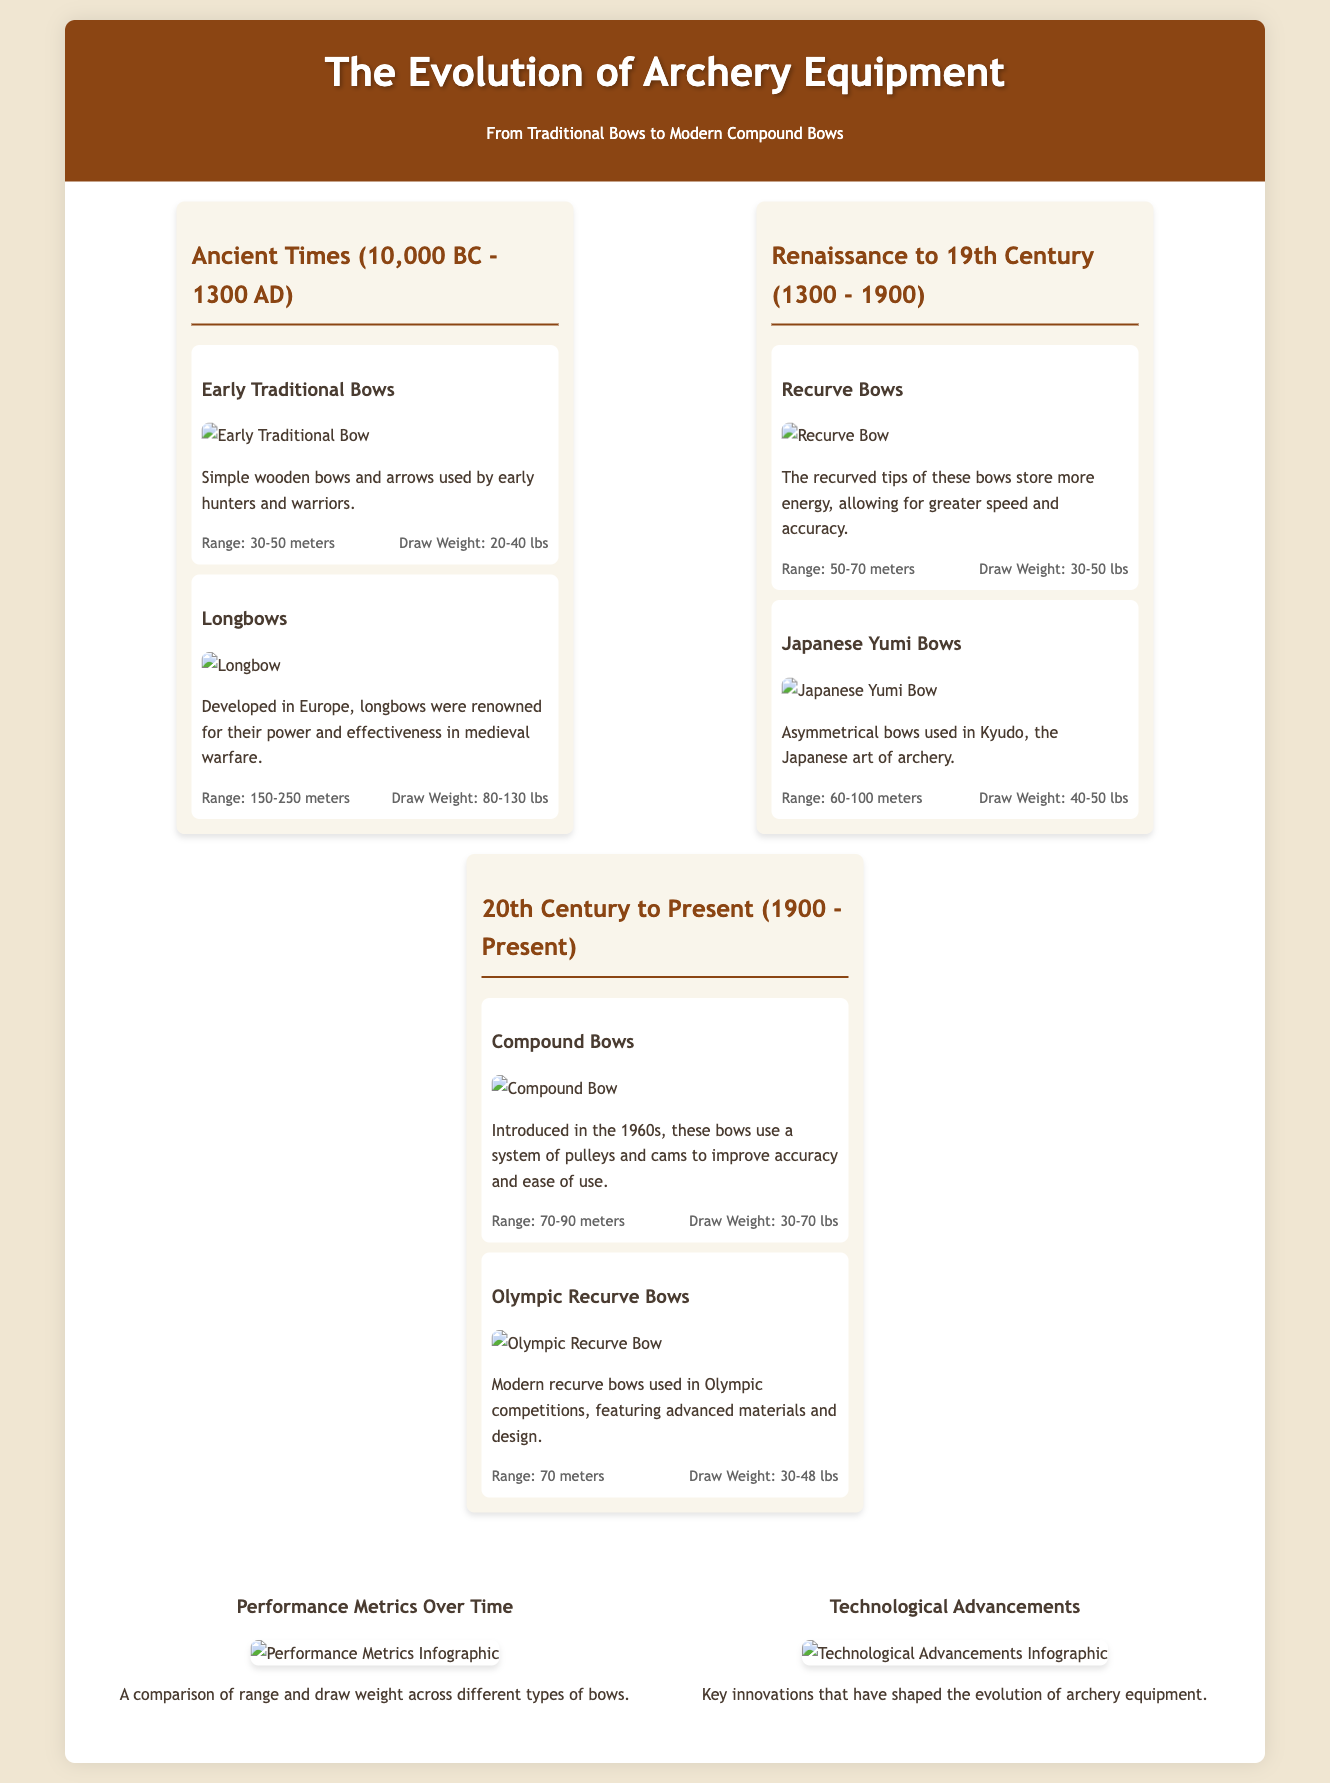What is the range of early traditional bows? The range of early traditional bows is mentioned in the document under the section for early traditional bows.
Answer: 30-50 meters What type of bow was developed in Europe known for its power? The document states that longbows were renowned for their power and effectiveness in medieval warfare.
Answer: Longbows What is the draw weight of Olympic recurve bows? The draw weight for Olympic recurve bows is provided in their respective section.
Answer: 30-48 lbs What year were compound bows introduced? The document specifies that compound bows were introduced in the 1960s.
Answer: 1960s Which bow in the Renaissance to 19th Century era is known for storing more energy? The document mentions that recurved bows store more energy, allowing for greater speed and accuracy.
Answer: Recurve Bows What is the primary innovation of modern compound bows? The document discusses that compound bows use a system of pulleys and cams to improve accuracy and ease of use.
Answer: Pulleys and cams How many types of bows are mentioned in the 20th Century to Present era? The document lists two types of bows in the 20th Century to Present era.
Answer: Two What is the total number of eras covered in the timeline? The document contains three distinct eras related to the evolution of archery equipment.
Answer: Three What infographic compares range and draw weight? The document details an infographic that compares these metrics across different types of bows.
Answer: Performance Metrics Over Time 